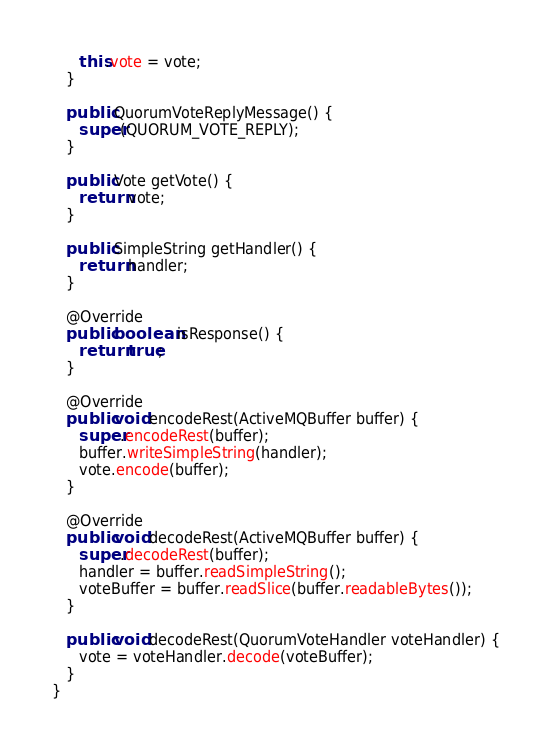<code> <loc_0><loc_0><loc_500><loc_500><_Java_>      this.vote = vote;
   }

   public QuorumVoteReplyMessage() {
      super(QUORUM_VOTE_REPLY);
   }

   public Vote getVote() {
      return vote;
   }

   public SimpleString getHandler() {
      return handler;
   }

   @Override
   public boolean isResponse() {
      return true;
   }

   @Override
   public void encodeRest(ActiveMQBuffer buffer) {
      super.encodeRest(buffer);
      buffer.writeSimpleString(handler);
      vote.encode(buffer);
   }

   @Override
   public void decodeRest(ActiveMQBuffer buffer) {
      super.decodeRest(buffer);
      handler = buffer.readSimpleString();
      voteBuffer = buffer.readSlice(buffer.readableBytes());
   }

   public void decodeRest(QuorumVoteHandler voteHandler) {
      vote = voteHandler.decode(voteBuffer);
   }
}
</code> 